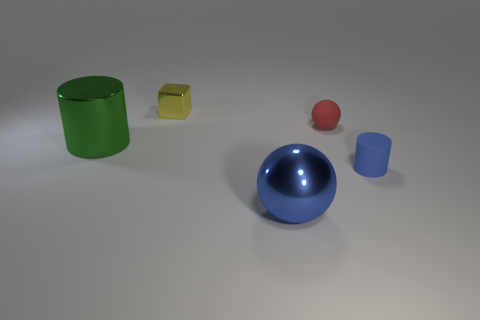Is there a thing that has the same color as the metal ball?
Your response must be concise. Yes. There is a small cylinder that is the same color as the large metal ball; what is its material?
Make the answer very short. Rubber. There is a metal thing that is the same color as the small matte cylinder; what is its size?
Your answer should be compact. Large. Is the shiny ball the same color as the tiny rubber cylinder?
Provide a succinct answer. Yes. Is there any other thing of the same color as the rubber cylinder?
Your answer should be very brief. Yes. There is a metallic thing in front of the small cylinder; is it the same color as the cylinder in front of the large metal cylinder?
Your answer should be compact. Yes. How many objects are both in front of the large green shiny object and behind the large green cylinder?
Your answer should be compact. 0. What size is the green cylinder that is the same material as the large blue sphere?
Make the answer very short. Large. The yellow metal thing has what size?
Provide a short and direct response. Small. What material is the small cylinder?
Provide a succinct answer. Rubber. 